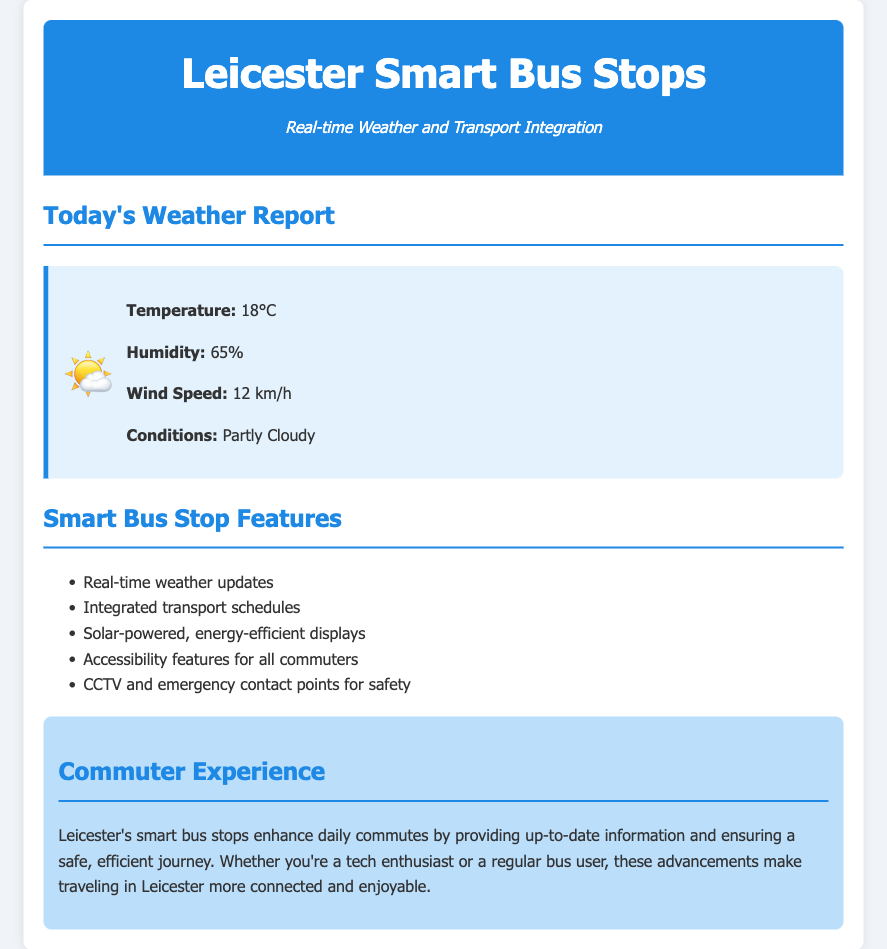what is the temperature today? The document states today's temperature as 18°C.
Answer: 18°C what is the humidity level? The humidity level mentioned in the document is 65%.
Answer: 65% how fast is the wind blowing? The document indicates a wind speed of 12 km/h.
Answer: 12 km/h what are the weather conditions? The document describes the weather conditions as partly cloudy.
Answer: Partly Cloudy what feature of smart bus stops ensures commuter safety? The document lists CCTV and emergency contact points as features for safety.
Answer: CCTV and emergency contact points how does the smart bus stops enhance the commuter experience? The document mentions that these stops provide up-to-date information and ensure a safe, efficient journey, enhancing the commuter experience.
Answer: Up-to-date information and safe, efficient journey what energy source do the smart bus stops use? The document states that the smart bus stops are solar-powered.
Answer: Solar-powered what is the purpose of the accessibility features? The document includes accessibility features for all commuters, ensuring inclusivity.
Answer: Ensuring inclusivity 